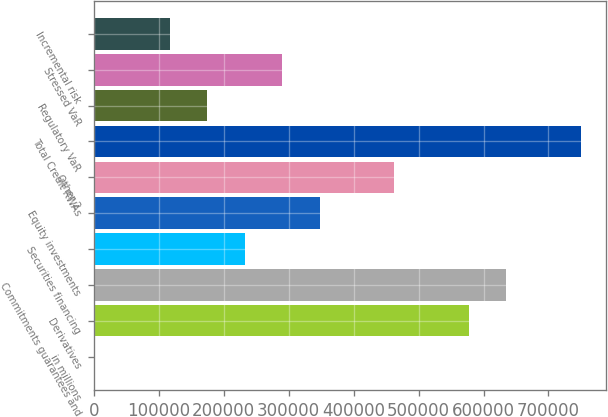<chart> <loc_0><loc_0><loc_500><loc_500><bar_chart><fcel>in millions<fcel>Derivatives<fcel>Commitments guarantees and<fcel>Securities financing<fcel>Equity investments<fcel>Other 2<fcel>Total Credit RWAs<fcel>Regulatory VaR<fcel>Stressed VaR<fcel>Incremental risk<nl><fcel>2015<fcel>577651<fcel>635215<fcel>232269<fcel>347397<fcel>462524<fcel>750342<fcel>174706<fcel>289833<fcel>117142<nl></chart> 